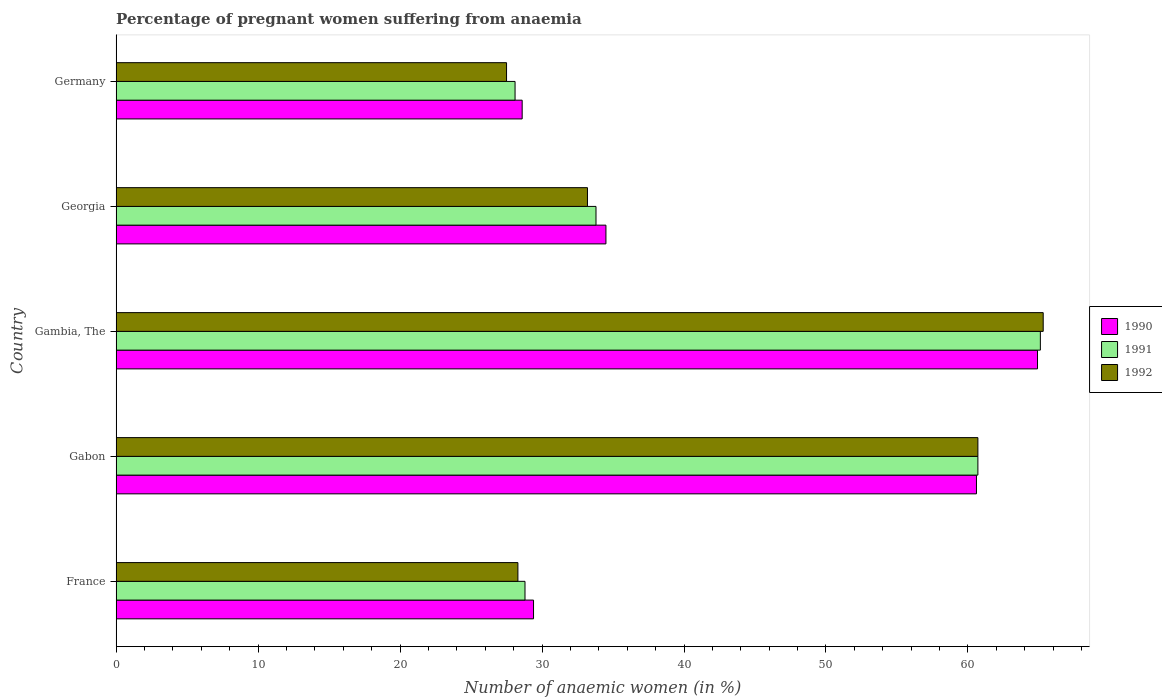How many different coloured bars are there?
Offer a terse response. 3. How many groups of bars are there?
Make the answer very short. 5. How many bars are there on the 2nd tick from the bottom?
Your response must be concise. 3. What is the label of the 3rd group of bars from the top?
Offer a very short reply. Gambia, The. In how many cases, is the number of bars for a given country not equal to the number of legend labels?
Provide a short and direct response. 0. What is the number of anaemic women in 1990 in Gambia, The?
Keep it short and to the point. 64.9. Across all countries, what is the maximum number of anaemic women in 1991?
Offer a terse response. 65.1. Across all countries, what is the minimum number of anaemic women in 1991?
Give a very brief answer. 28.1. In which country was the number of anaemic women in 1991 maximum?
Provide a succinct answer. Gambia, The. What is the total number of anaemic women in 1992 in the graph?
Your response must be concise. 215. What is the difference between the number of anaemic women in 1991 in Gabon and that in Georgia?
Keep it short and to the point. 26.9. What is the difference between the number of anaemic women in 1992 in Gambia, The and the number of anaemic women in 1991 in Germany?
Provide a short and direct response. 37.2. What is the average number of anaemic women in 1991 per country?
Ensure brevity in your answer.  43.3. What is the difference between the number of anaemic women in 1990 and number of anaemic women in 1992 in Georgia?
Your response must be concise. 1.3. What is the ratio of the number of anaemic women in 1992 in France to that in Gambia, The?
Your answer should be compact. 0.43. Is the number of anaemic women in 1991 in Gambia, The less than that in Germany?
Give a very brief answer. No. Is the difference between the number of anaemic women in 1990 in France and Germany greater than the difference between the number of anaemic women in 1992 in France and Germany?
Your answer should be compact. No. What is the difference between the highest and the second highest number of anaemic women in 1990?
Provide a short and direct response. 4.3. What is the difference between the highest and the lowest number of anaemic women in 1990?
Your answer should be compact. 36.3. In how many countries, is the number of anaemic women in 1991 greater than the average number of anaemic women in 1991 taken over all countries?
Make the answer very short. 2. What does the 1st bar from the top in Gambia, The represents?
Make the answer very short. 1992. What does the 3rd bar from the bottom in France represents?
Offer a very short reply. 1992. Is it the case that in every country, the sum of the number of anaemic women in 1992 and number of anaemic women in 1991 is greater than the number of anaemic women in 1990?
Your answer should be very brief. Yes. What is the difference between two consecutive major ticks on the X-axis?
Keep it short and to the point. 10. Does the graph contain any zero values?
Offer a terse response. No. Does the graph contain grids?
Keep it short and to the point. No. Where does the legend appear in the graph?
Provide a short and direct response. Center right. How many legend labels are there?
Your answer should be compact. 3. What is the title of the graph?
Your answer should be very brief. Percentage of pregnant women suffering from anaemia. What is the label or title of the X-axis?
Ensure brevity in your answer.  Number of anaemic women (in %). What is the label or title of the Y-axis?
Offer a terse response. Country. What is the Number of anaemic women (in %) in 1990 in France?
Offer a very short reply. 29.4. What is the Number of anaemic women (in %) in 1991 in France?
Give a very brief answer. 28.8. What is the Number of anaemic women (in %) in 1992 in France?
Offer a terse response. 28.3. What is the Number of anaemic women (in %) in 1990 in Gabon?
Offer a very short reply. 60.6. What is the Number of anaemic women (in %) of 1991 in Gabon?
Offer a very short reply. 60.7. What is the Number of anaemic women (in %) of 1992 in Gabon?
Give a very brief answer. 60.7. What is the Number of anaemic women (in %) in 1990 in Gambia, The?
Give a very brief answer. 64.9. What is the Number of anaemic women (in %) of 1991 in Gambia, The?
Ensure brevity in your answer.  65.1. What is the Number of anaemic women (in %) in 1992 in Gambia, The?
Your response must be concise. 65.3. What is the Number of anaemic women (in %) of 1990 in Georgia?
Offer a very short reply. 34.5. What is the Number of anaemic women (in %) in 1991 in Georgia?
Your response must be concise. 33.8. What is the Number of anaemic women (in %) of 1992 in Georgia?
Your answer should be very brief. 33.2. What is the Number of anaemic women (in %) in 1990 in Germany?
Offer a very short reply. 28.6. What is the Number of anaemic women (in %) of 1991 in Germany?
Provide a short and direct response. 28.1. What is the Number of anaemic women (in %) of 1992 in Germany?
Your answer should be very brief. 27.5. Across all countries, what is the maximum Number of anaemic women (in %) in 1990?
Ensure brevity in your answer.  64.9. Across all countries, what is the maximum Number of anaemic women (in %) in 1991?
Provide a short and direct response. 65.1. Across all countries, what is the maximum Number of anaemic women (in %) in 1992?
Give a very brief answer. 65.3. Across all countries, what is the minimum Number of anaemic women (in %) of 1990?
Keep it short and to the point. 28.6. Across all countries, what is the minimum Number of anaemic women (in %) of 1991?
Your answer should be compact. 28.1. What is the total Number of anaemic women (in %) in 1990 in the graph?
Ensure brevity in your answer.  218. What is the total Number of anaemic women (in %) in 1991 in the graph?
Your answer should be very brief. 216.5. What is the total Number of anaemic women (in %) in 1992 in the graph?
Your answer should be very brief. 215. What is the difference between the Number of anaemic women (in %) of 1990 in France and that in Gabon?
Offer a terse response. -31.2. What is the difference between the Number of anaemic women (in %) in 1991 in France and that in Gabon?
Your response must be concise. -31.9. What is the difference between the Number of anaemic women (in %) of 1992 in France and that in Gabon?
Keep it short and to the point. -32.4. What is the difference between the Number of anaemic women (in %) of 1990 in France and that in Gambia, The?
Make the answer very short. -35.5. What is the difference between the Number of anaemic women (in %) in 1991 in France and that in Gambia, The?
Provide a short and direct response. -36.3. What is the difference between the Number of anaemic women (in %) in 1992 in France and that in Gambia, The?
Give a very brief answer. -37. What is the difference between the Number of anaemic women (in %) of 1990 in France and that in Germany?
Ensure brevity in your answer.  0.8. What is the difference between the Number of anaemic women (in %) of 1992 in France and that in Germany?
Your answer should be very brief. 0.8. What is the difference between the Number of anaemic women (in %) of 1992 in Gabon and that in Gambia, The?
Offer a very short reply. -4.6. What is the difference between the Number of anaemic women (in %) in 1990 in Gabon and that in Georgia?
Your answer should be compact. 26.1. What is the difference between the Number of anaemic women (in %) of 1991 in Gabon and that in Georgia?
Your response must be concise. 26.9. What is the difference between the Number of anaemic women (in %) in 1992 in Gabon and that in Georgia?
Ensure brevity in your answer.  27.5. What is the difference between the Number of anaemic women (in %) of 1990 in Gabon and that in Germany?
Keep it short and to the point. 32. What is the difference between the Number of anaemic women (in %) of 1991 in Gabon and that in Germany?
Your answer should be compact. 32.6. What is the difference between the Number of anaemic women (in %) in 1992 in Gabon and that in Germany?
Your answer should be compact. 33.2. What is the difference between the Number of anaemic women (in %) of 1990 in Gambia, The and that in Georgia?
Keep it short and to the point. 30.4. What is the difference between the Number of anaemic women (in %) of 1991 in Gambia, The and that in Georgia?
Ensure brevity in your answer.  31.3. What is the difference between the Number of anaemic women (in %) of 1992 in Gambia, The and that in Georgia?
Keep it short and to the point. 32.1. What is the difference between the Number of anaemic women (in %) in 1990 in Gambia, The and that in Germany?
Make the answer very short. 36.3. What is the difference between the Number of anaemic women (in %) of 1991 in Gambia, The and that in Germany?
Provide a short and direct response. 37. What is the difference between the Number of anaemic women (in %) in 1992 in Gambia, The and that in Germany?
Your answer should be very brief. 37.8. What is the difference between the Number of anaemic women (in %) in 1991 in Georgia and that in Germany?
Make the answer very short. 5.7. What is the difference between the Number of anaemic women (in %) in 1990 in France and the Number of anaemic women (in %) in 1991 in Gabon?
Offer a very short reply. -31.3. What is the difference between the Number of anaemic women (in %) in 1990 in France and the Number of anaemic women (in %) in 1992 in Gabon?
Offer a terse response. -31.3. What is the difference between the Number of anaemic women (in %) of 1991 in France and the Number of anaemic women (in %) of 1992 in Gabon?
Your response must be concise. -31.9. What is the difference between the Number of anaemic women (in %) in 1990 in France and the Number of anaemic women (in %) in 1991 in Gambia, The?
Keep it short and to the point. -35.7. What is the difference between the Number of anaemic women (in %) of 1990 in France and the Number of anaemic women (in %) of 1992 in Gambia, The?
Offer a terse response. -35.9. What is the difference between the Number of anaemic women (in %) of 1991 in France and the Number of anaemic women (in %) of 1992 in Gambia, The?
Provide a succinct answer. -36.5. What is the difference between the Number of anaemic women (in %) of 1990 in France and the Number of anaemic women (in %) of 1991 in Georgia?
Ensure brevity in your answer.  -4.4. What is the difference between the Number of anaemic women (in %) of 1990 in France and the Number of anaemic women (in %) of 1992 in Georgia?
Provide a succinct answer. -3.8. What is the difference between the Number of anaemic women (in %) in 1991 in France and the Number of anaemic women (in %) in 1992 in Georgia?
Keep it short and to the point. -4.4. What is the difference between the Number of anaemic women (in %) of 1990 in France and the Number of anaemic women (in %) of 1991 in Germany?
Your answer should be very brief. 1.3. What is the difference between the Number of anaemic women (in %) in 1990 in France and the Number of anaemic women (in %) in 1992 in Germany?
Ensure brevity in your answer.  1.9. What is the difference between the Number of anaemic women (in %) of 1991 in France and the Number of anaemic women (in %) of 1992 in Germany?
Make the answer very short. 1.3. What is the difference between the Number of anaemic women (in %) in 1990 in Gabon and the Number of anaemic women (in %) in 1992 in Gambia, The?
Keep it short and to the point. -4.7. What is the difference between the Number of anaemic women (in %) in 1990 in Gabon and the Number of anaemic women (in %) in 1991 in Georgia?
Offer a terse response. 26.8. What is the difference between the Number of anaemic women (in %) of 1990 in Gabon and the Number of anaemic women (in %) of 1992 in Georgia?
Offer a terse response. 27.4. What is the difference between the Number of anaemic women (in %) in 1991 in Gabon and the Number of anaemic women (in %) in 1992 in Georgia?
Offer a very short reply. 27.5. What is the difference between the Number of anaemic women (in %) of 1990 in Gabon and the Number of anaemic women (in %) of 1991 in Germany?
Offer a terse response. 32.5. What is the difference between the Number of anaemic women (in %) in 1990 in Gabon and the Number of anaemic women (in %) in 1992 in Germany?
Your answer should be compact. 33.1. What is the difference between the Number of anaemic women (in %) in 1991 in Gabon and the Number of anaemic women (in %) in 1992 in Germany?
Provide a succinct answer. 33.2. What is the difference between the Number of anaemic women (in %) of 1990 in Gambia, The and the Number of anaemic women (in %) of 1991 in Georgia?
Offer a very short reply. 31.1. What is the difference between the Number of anaemic women (in %) in 1990 in Gambia, The and the Number of anaemic women (in %) in 1992 in Georgia?
Ensure brevity in your answer.  31.7. What is the difference between the Number of anaemic women (in %) of 1991 in Gambia, The and the Number of anaemic women (in %) of 1992 in Georgia?
Offer a very short reply. 31.9. What is the difference between the Number of anaemic women (in %) of 1990 in Gambia, The and the Number of anaemic women (in %) of 1991 in Germany?
Ensure brevity in your answer.  36.8. What is the difference between the Number of anaemic women (in %) of 1990 in Gambia, The and the Number of anaemic women (in %) of 1992 in Germany?
Make the answer very short. 37.4. What is the difference between the Number of anaemic women (in %) in 1991 in Gambia, The and the Number of anaemic women (in %) in 1992 in Germany?
Your answer should be very brief. 37.6. What is the difference between the Number of anaemic women (in %) in 1991 in Georgia and the Number of anaemic women (in %) in 1992 in Germany?
Your response must be concise. 6.3. What is the average Number of anaemic women (in %) of 1990 per country?
Your answer should be very brief. 43.6. What is the average Number of anaemic women (in %) of 1991 per country?
Ensure brevity in your answer.  43.3. What is the difference between the Number of anaemic women (in %) of 1991 and Number of anaemic women (in %) of 1992 in France?
Give a very brief answer. 0.5. What is the difference between the Number of anaemic women (in %) of 1990 and Number of anaemic women (in %) of 1992 in Gabon?
Keep it short and to the point. -0.1. What is the difference between the Number of anaemic women (in %) of 1991 and Number of anaemic women (in %) of 1992 in Gambia, The?
Provide a succinct answer. -0.2. What is the difference between the Number of anaemic women (in %) in 1990 and Number of anaemic women (in %) in 1991 in Georgia?
Give a very brief answer. 0.7. What is the difference between the Number of anaemic women (in %) in 1990 and Number of anaemic women (in %) in 1991 in Germany?
Ensure brevity in your answer.  0.5. What is the difference between the Number of anaemic women (in %) in 1990 and Number of anaemic women (in %) in 1992 in Germany?
Keep it short and to the point. 1.1. What is the difference between the Number of anaemic women (in %) of 1991 and Number of anaemic women (in %) of 1992 in Germany?
Keep it short and to the point. 0.6. What is the ratio of the Number of anaemic women (in %) of 1990 in France to that in Gabon?
Provide a succinct answer. 0.49. What is the ratio of the Number of anaemic women (in %) of 1991 in France to that in Gabon?
Give a very brief answer. 0.47. What is the ratio of the Number of anaemic women (in %) in 1992 in France to that in Gabon?
Offer a terse response. 0.47. What is the ratio of the Number of anaemic women (in %) in 1990 in France to that in Gambia, The?
Make the answer very short. 0.45. What is the ratio of the Number of anaemic women (in %) in 1991 in France to that in Gambia, The?
Ensure brevity in your answer.  0.44. What is the ratio of the Number of anaemic women (in %) of 1992 in France to that in Gambia, The?
Offer a terse response. 0.43. What is the ratio of the Number of anaemic women (in %) in 1990 in France to that in Georgia?
Offer a terse response. 0.85. What is the ratio of the Number of anaemic women (in %) in 1991 in France to that in Georgia?
Provide a short and direct response. 0.85. What is the ratio of the Number of anaemic women (in %) of 1992 in France to that in Georgia?
Your response must be concise. 0.85. What is the ratio of the Number of anaemic women (in %) in 1990 in France to that in Germany?
Keep it short and to the point. 1.03. What is the ratio of the Number of anaemic women (in %) in 1991 in France to that in Germany?
Offer a very short reply. 1.02. What is the ratio of the Number of anaemic women (in %) of 1992 in France to that in Germany?
Make the answer very short. 1.03. What is the ratio of the Number of anaemic women (in %) in 1990 in Gabon to that in Gambia, The?
Provide a short and direct response. 0.93. What is the ratio of the Number of anaemic women (in %) of 1991 in Gabon to that in Gambia, The?
Provide a short and direct response. 0.93. What is the ratio of the Number of anaemic women (in %) of 1992 in Gabon to that in Gambia, The?
Provide a succinct answer. 0.93. What is the ratio of the Number of anaemic women (in %) in 1990 in Gabon to that in Georgia?
Provide a short and direct response. 1.76. What is the ratio of the Number of anaemic women (in %) of 1991 in Gabon to that in Georgia?
Keep it short and to the point. 1.8. What is the ratio of the Number of anaemic women (in %) in 1992 in Gabon to that in Georgia?
Ensure brevity in your answer.  1.83. What is the ratio of the Number of anaemic women (in %) of 1990 in Gabon to that in Germany?
Make the answer very short. 2.12. What is the ratio of the Number of anaemic women (in %) in 1991 in Gabon to that in Germany?
Your response must be concise. 2.16. What is the ratio of the Number of anaemic women (in %) in 1992 in Gabon to that in Germany?
Keep it short and to the point. 2.21. What is the ratio of the Number of anaemic women (in %) of 1990 in Gambia, The to that in Georgia?
Your response must be concise. 1.88. What is the ratio of the Number of anaemic women (in %) in 1991 in Gambia, The to that in Georgia?
Your response must be concise. 1.93. What is the ratio of the Number of anaemic women (in %) of 1992 in Gambia, The to that in Georgia?
Ensure brevity in your answer.  1.97. What is the ratio of the Number of anaemic women (in %) of 1990 in Gambia, The to that in Germany?
Provide a succinct answer. 2.27. What is the ratio of the Number of anaemic women (in %) of 1991 in Gambia, The to that in Germany?
Offer a terse response. 2.32. What is the ratio of the Number of anaemic women (in %) of 1992 in Gambia, The to that in Germany?
Offer a very short reply. 2.37. What is the ratio of the Number of anaemic women (in %) of 1990 in Georgia to that in Germany?
Provide a short and direct response. 1.21. What is the ratio of the Number of anaemic women (in %) in 1991 in Georgia to that in Germany?
Make the answer very short. 1.2. What is the ratio of the Number of anaemic women (in %) of 1992 in Georgia to that in Germany?
Give a very brief answer. 1.21. What is the difference between the highest and the second highest Number of anaemic women (in %) in 1990?
Provide a succinct answer. 4.3. What is the difference between the highest and the second highest Number of anaemic women (in %) of 1992?
Offer a terse response. 4.6. What is the difference between the highest and the lowest Number of anaemic women (in %) in 1990?
Your answer should be very brief. 36.3. What is the difference between the highest and the lowest Number of anaemic women (in %) of 1992?
Ensure brevity in your answer.  37.8. 